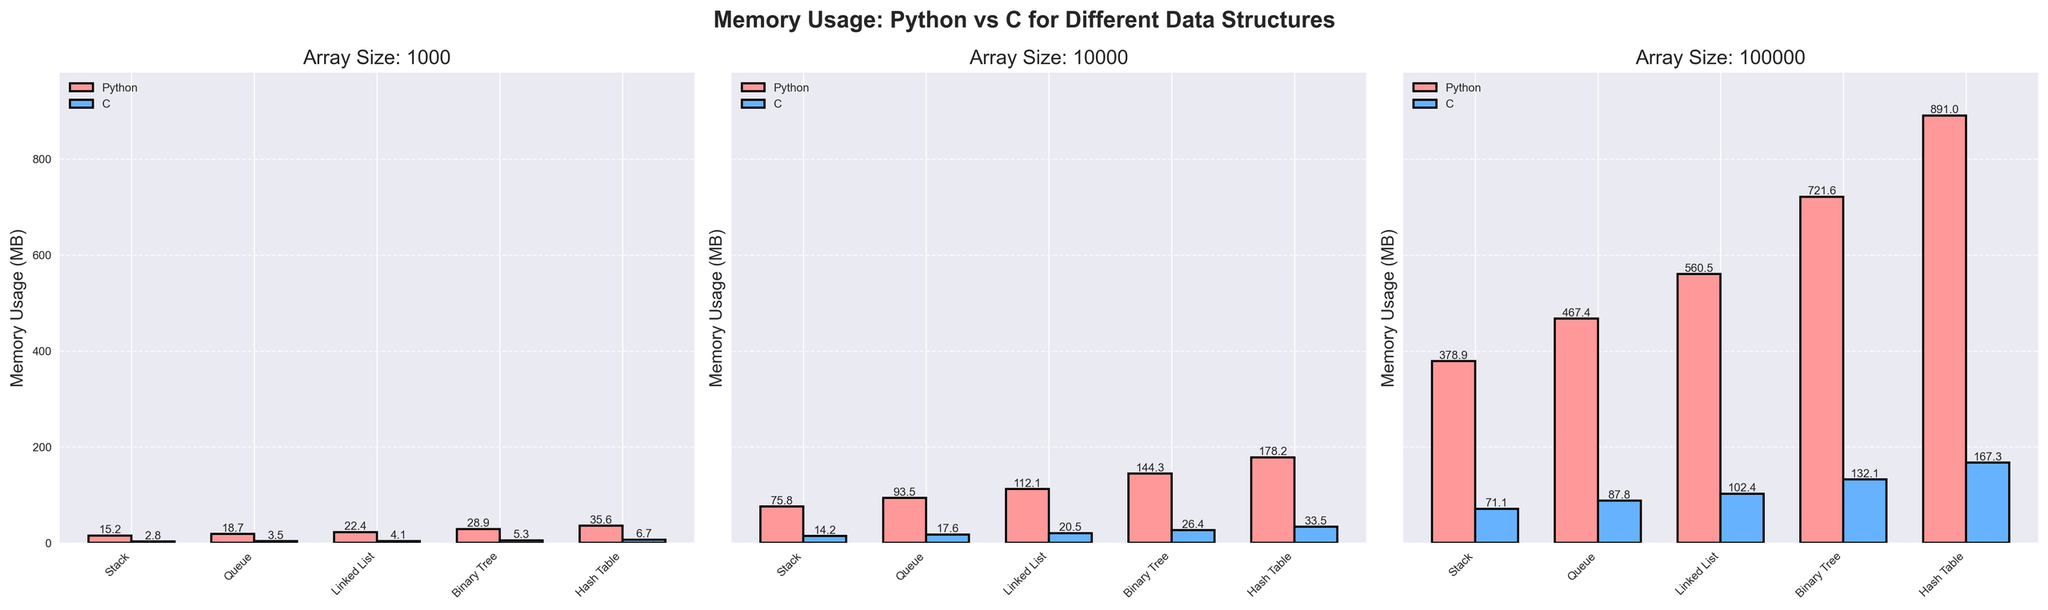Which data structure has the highest memory usage in Python for an array size of 10000? To determine this, look at the bars representing Python memory usage in the subplot labeled "Array Size: 10000". The "Hash Table" has the highest bar indicating the largest memory usage.
Answer: Hash Table For array size 1000, what is the difference in memory usage between the Hash Table and the Stack in Python? Identify the memory usage values for Hash Table and Stack in Python for array size 1000. Hash Table uses 35.6 MB and Stack uses 15.2 MB. The difference is 35.6 - 15.2.
Answer: 20.4 MB Is the memory usage of Python ever less than C for any data structure or array size? Inspect all the subplots and compare each pair of Python and C bars for each data structure and array size. Python memory usage is always higher than C’s for every configuration shown.
Answer: No What is the average memory usage of Linked List in C across all array sizes? Add the memory usage values for Linked List in C across all sizes (4.1, 20.5, 102.4). Then divide by the number of sizes (3). (4.1 + 20.5 + 102.4) / 3
Answer: 42.33 MB How much more memory does a Binary Tree in Python consume compared to C for an array size of 10000? Identify memory usage values for Binary Tree in Python and C for array size 10000. Python uses 144.3 MB, and C uses 26.4 MB. The difference is 144.3 - 26.4.
Answer: 117.9 MB Which color is used to represent Python memory usage in the plots? Look at the legend or the bar colors; the bars representing Python memory usage are labeled and colored consistently. Python bars are colored red.
Answer: Red Compare the memory usage trend for Stacks in Python versus C from array size 1000 to 100000. What do you notice? Observe the bar heights for Stacks in both Python and C across the three subplots for varying array sizes. Both memory usages increase, but Python's memory usage increases at a much higher rate compared to C.
Answer: Python increases faster For array size 100000, what is the total memory used by all data structures combined in C? Sum the memory usage values for all data structures in C for array size 100000 (71.1 + 87.8 + 102.4 + 132.1 + 167.3).
Answer: 560.7 MB 